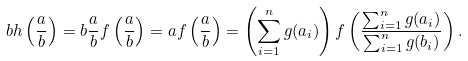Convert formula to latex. <formula><loc_0><loc_0><loc_500><loc_500>b h \left ( \frac { a } { b } \right ) = b \frac { a } { b } f \left ( \frac { a } { b } \right ) = a f \left ( \frac { a } { b } \right ) = \left ( \sum _ { i = 1 } ^ { n } g ( a _ { i } ) \right ) f \left ( \frac { \sum _ { i = 1 } ^ { n } g ( a _ { i } ) } { \sum _ { i = 1 } ^ { n } g ( b _ { i } ) } \right ) .</formula> 